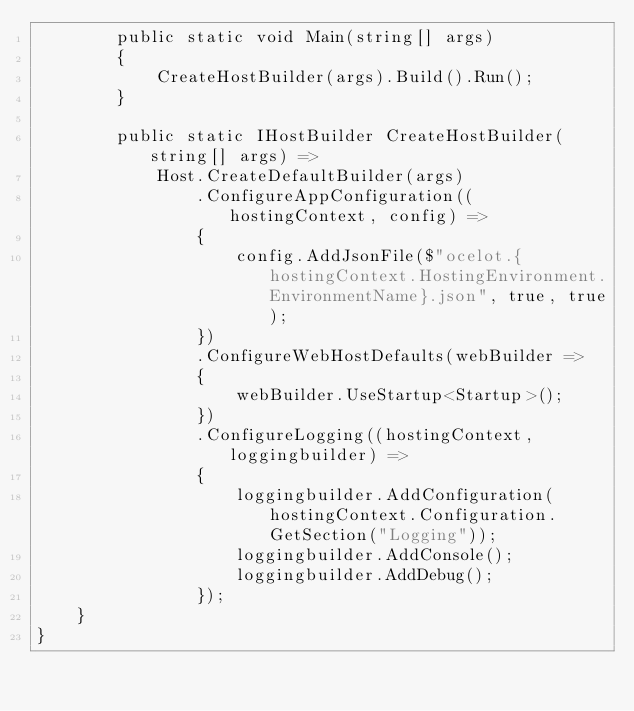Convert code to text. <code><loc_0><loc_0><loc_500><loc_500><_C#_>        public static void Main(string[] args)
        {
            CreateHostBuilder(args).Build().Run();
        }

        public static IHostBuilder CreateHostBuilder(string[] args) =>
            Host.CreateDefaultBuilder(args)
                .ConfigureAppConfiguration((hostingContext, config) => 
                {
                    config.AddJsonFile($"ocelot.{hostingContext.HostingEnvironment.EnvironmentName}.json", true, true);
                }) 
                .ConfigureWebHostDefaults(webBuilder =>
                {
                    webBuilder.UseStartup<Startup>();
                })
                .ConfigureLogging((hostingContext, loggingbuilder) => 
                {
                    loggingbuilder.AddConfiguration(hostingContext.Configuration.GetSection("Logging"));
                    loggingbuilder.AddConsole();
                    loggingbuilder.AddDebug();
                });
    }
}
</code> 